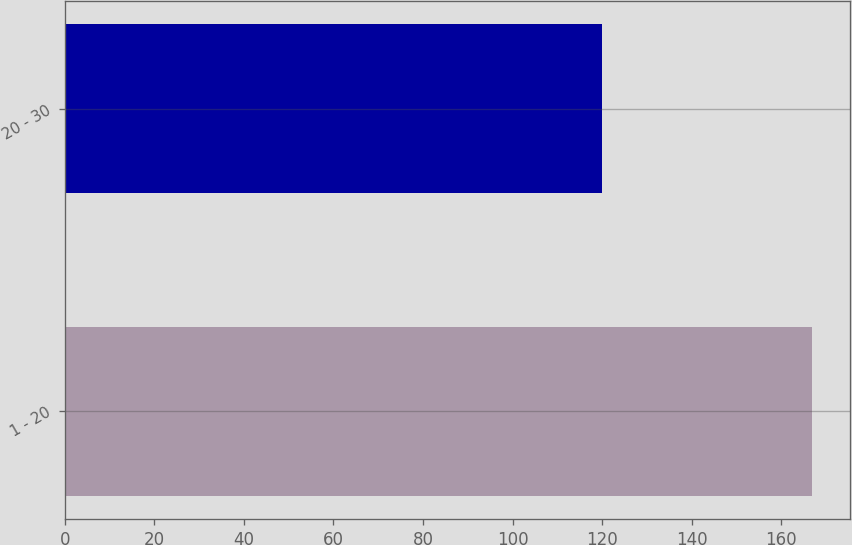Convert chart to OTSL. <chart><loc_0><loc_0><loc_500><loc_500><bar_chart><fcel>1 - 20<fcel>20 - 30<nl><fcel>167<fcel>120<nl></chart> 